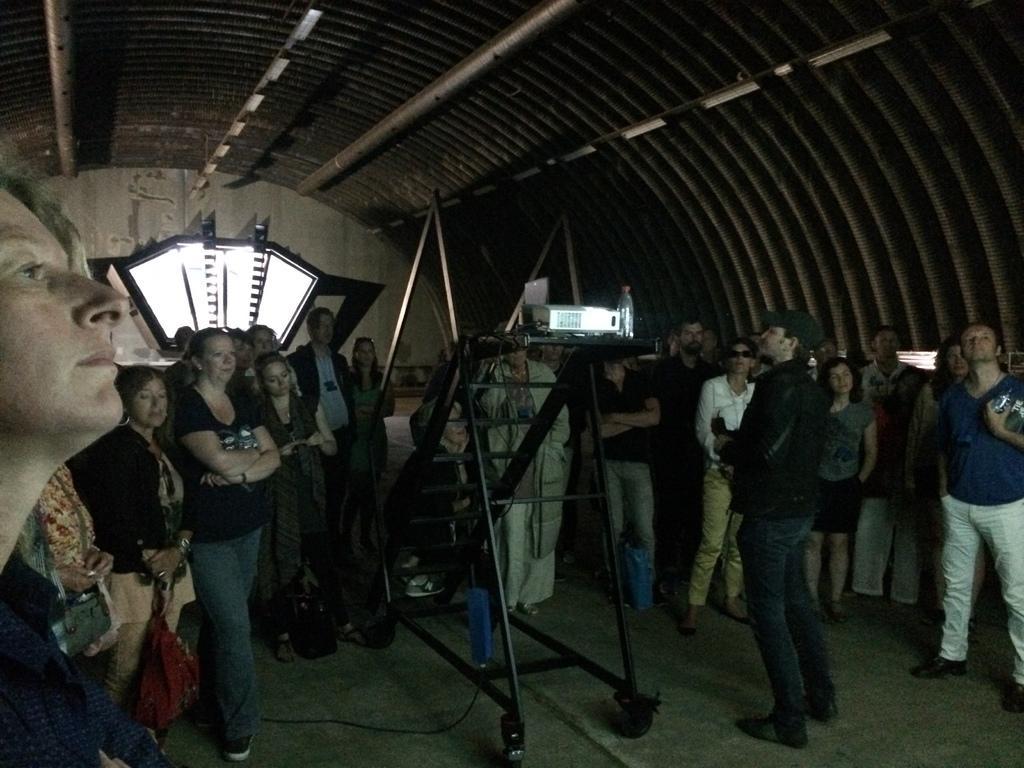How would you summarize this image in a sentence or two? In this image, I can see a group of people standing. These look like the stairs with the wheels. I can see a bottle and a projector placed on the stairs. In the background, It looks like a window. At the top of the image, I can see the iron rods. 